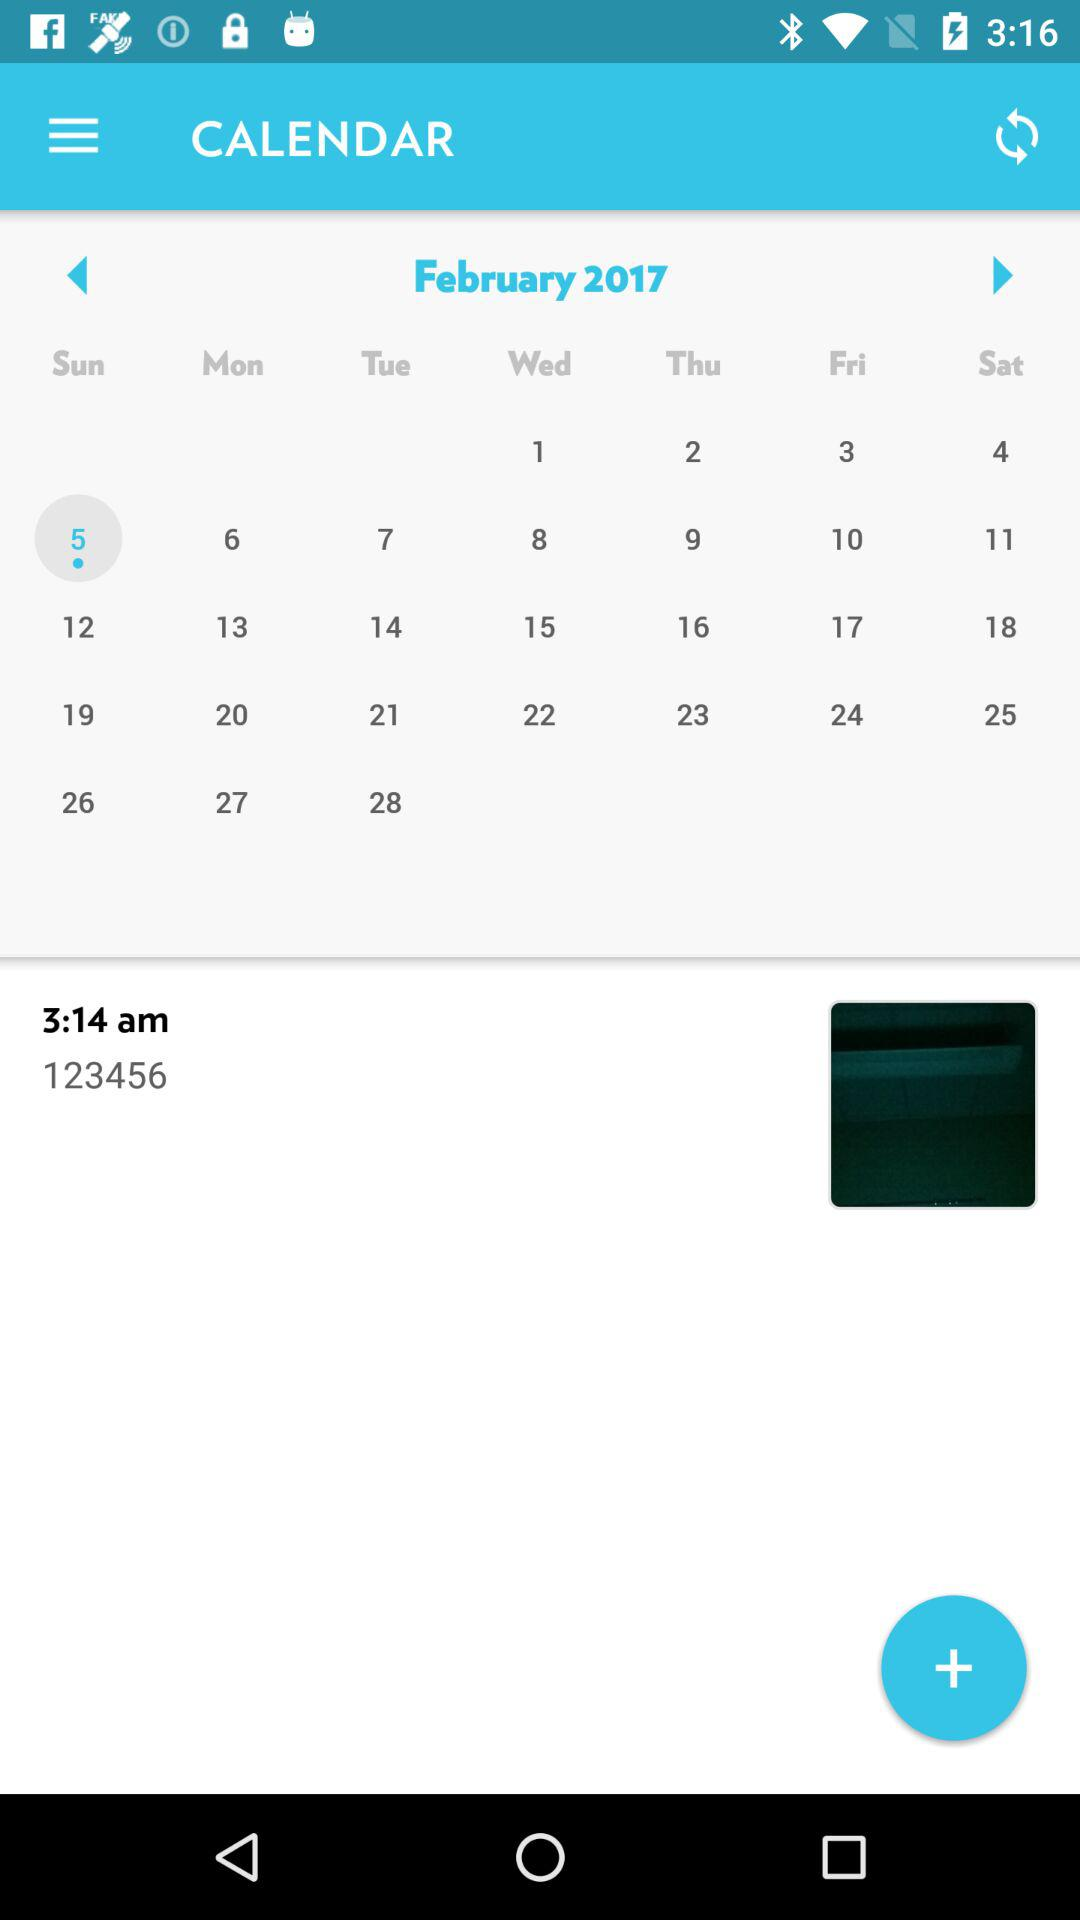What is the selected date? The selected date is Sunday, February 5, 2017. 